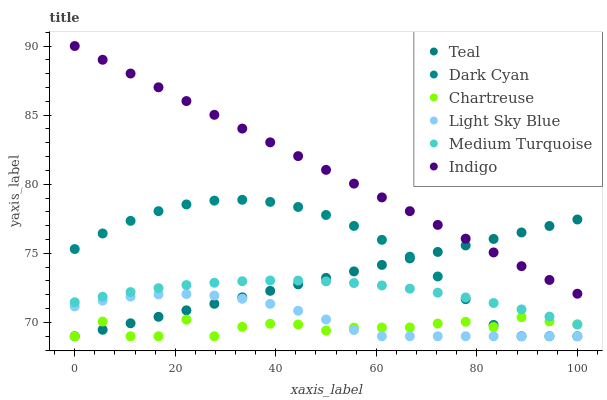Does Chartreuse have the minimum area under the curve?
Answer yes or no. Yes. Does Indigo have the maximum area under the curve?
Answer yes or no. Yes. Does Teal have the minimum area under the curve?
Answer yes or no. No. Does Teal have the maximum area under the curve?
Answer yes or no. No. Is Indigo the smoothest?
Answer yes or no. Yes. Is Chartreuse the roughest?
Answer yes or no. Yes. Is Teal the smoothest?
Answer yes or no. No. Is Teal the roughest?
Answer yes or no. No. Does Teal have the lowest value?
Answer yes or no. Yes. Does Medium Turquoise have the lowest value?
Answer yes or no. No. Does Indigo have the highest value?
Answer yes or no. Yes. Does Teal have the highest value?
Answer yes or no. No. Is Medium Turquoise less than Indigo?
Answer yes or no. Yes. Is Indigo greater than Dark Cyan?
Answer yes or no. Yes. Does Medium Turquoise intersect Chartreuse?
Answer yes or no. Yes. Is Medium Turquoise less than Chartreuse?
Answer yes or no. No. Is Medium Turquoise greater than Chartreuse?
Answer yes or no. No. Does Medium Turquoise intersect Indigo?
Answer yes or no. No. 